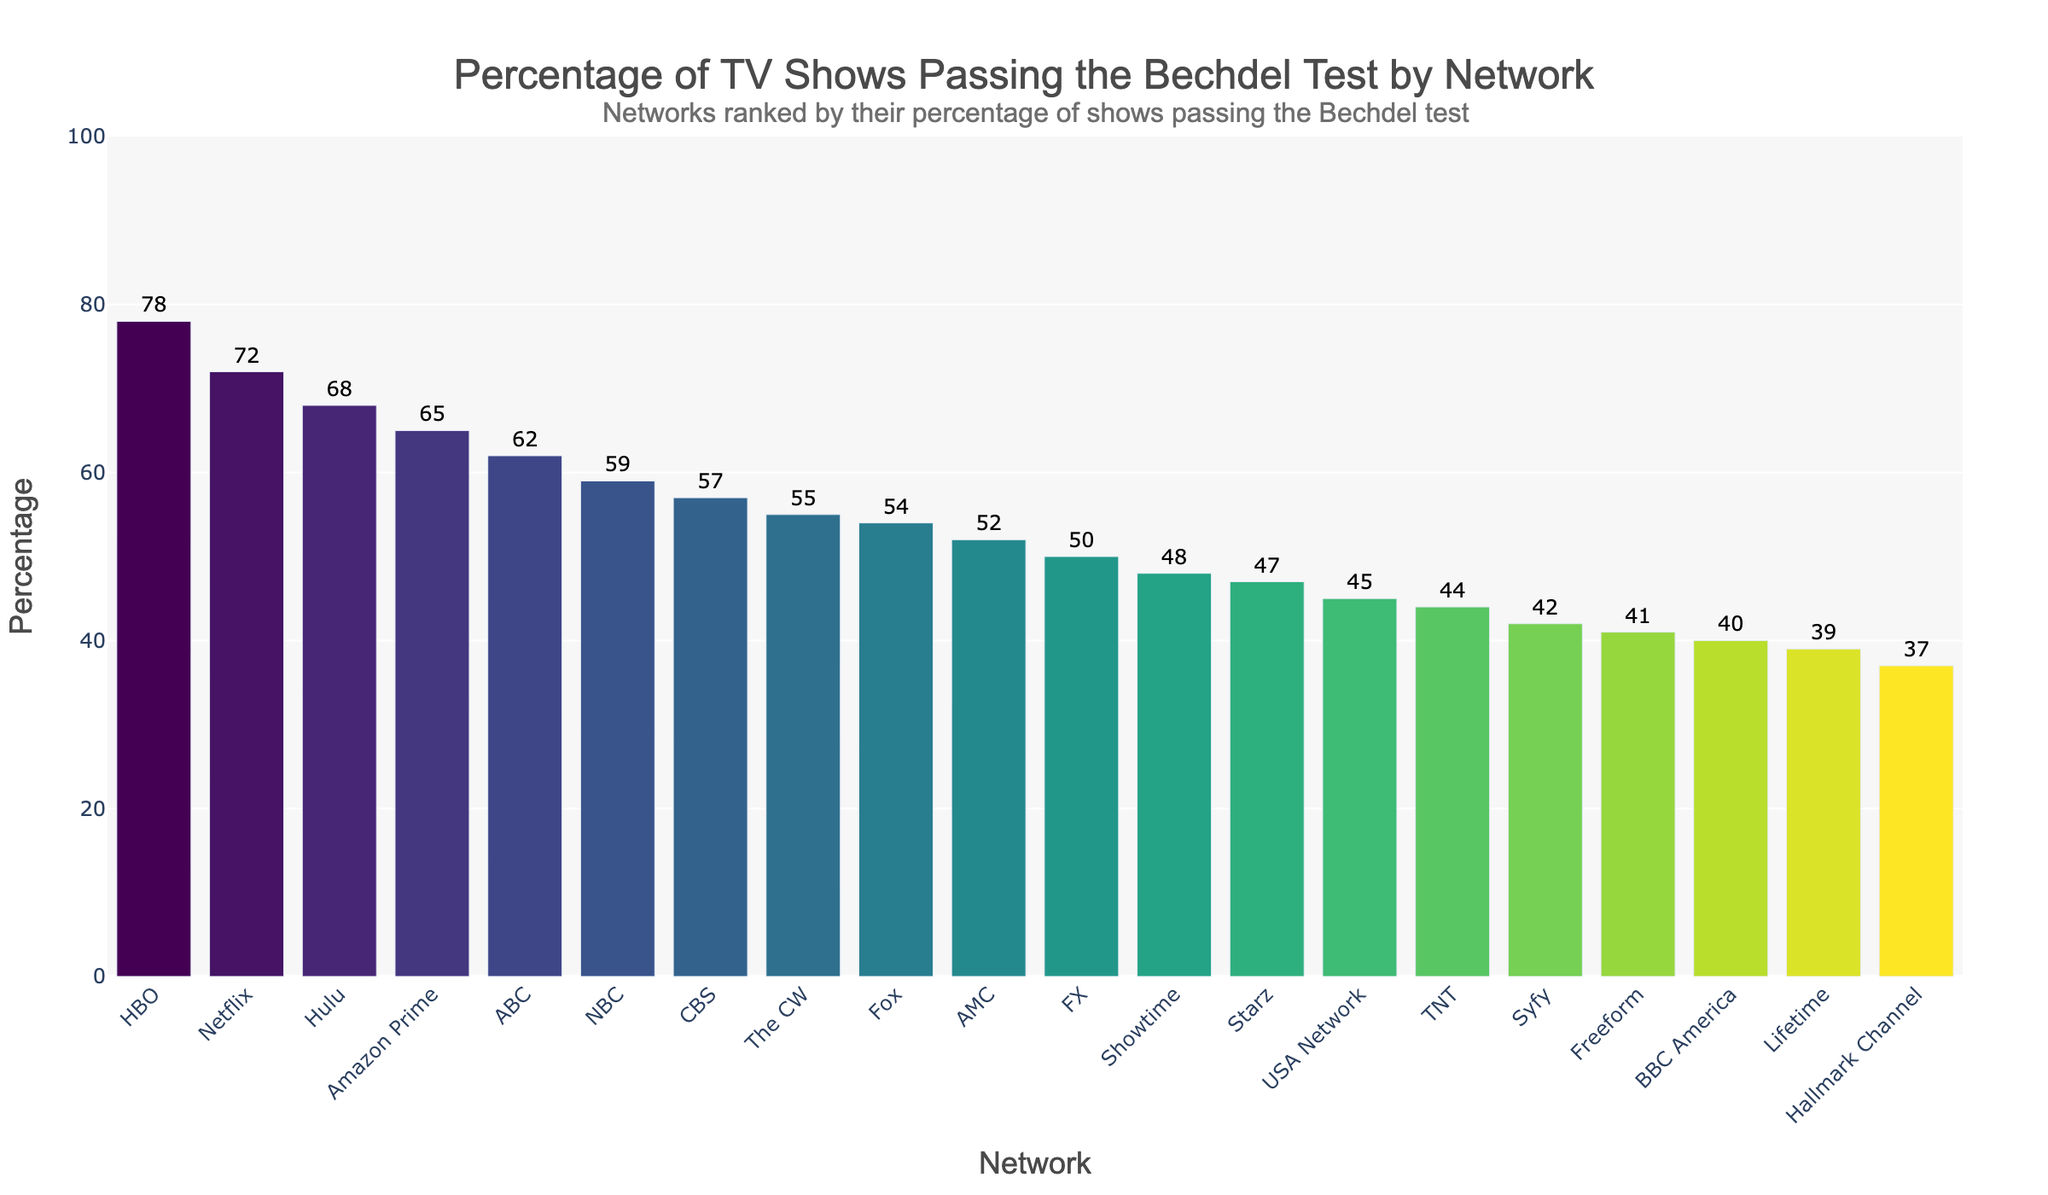What is the network with the highest percentage of TV shows passing the Bechdel test? The bar chart shows various networks and the percentage of TV shows passing the Bechdel test. The highest bar represents HBO with 78%.
Answer: HBO Which network has a higher percentage of TV shows passing the Bechdel test, Hulu or Amazon Prime? By comparing the heights of the bars for Hulu and Amazon Prime, we see that Hulu is at 68% and Amazon Prime is at 65%. Therefore, Hulu has a higher percentage.
Answer: Hulu What is the difference in percentage between the network with the highest and the network with the lowest percentage of TV shows passing the Bechdel test? The network with the highest percentage is HBO at 78%, and the network with the lowest percentage is Hallmark Channel at 37%. The difference is 78% - 37% = 41%.
Answer: 41% Which network is closest to having 50% of its TV shows passing the Bechdel test? Looking at the bars around the 50% mark, FX is shown as having exactly 50% of its TV shows passing the Bechdel test.
Answer: FX How many networks have at least 60% of their TV shows passing the Bechdel test? By counting the bars with percentages above or equal to 60%, the networks are HBO, Netflix, Hulu, Amazon Prime, and ABC. There are a total of 5 networks.
Answer: 5 What is the average percentage of TV shows passing the Bechdel test for NBC, CBS, and The CW? The percentages for NBC, CBS, and The CW are 59%, 57%, and 55%. The sum of these percentages is 59 + 57 + 55 = 171. The average is 171/3 = 57%.
Answer: 57% Which networks have a percentage of TV shows passing the Bechdel test that is higher than the median percentage of all networks? First, we need to find the median percentage. There are 20 data points, so the median is the average of the 10th and 11th values. The 10th and 11th values are AMC (52%) and FX (50%). The median is (52 + 50)/2 = 51%. Networks with more than 51% are HBO, Netflix, Hulu, Amazon Prime, ABC, NBC, CBS, The CW, Fox, and AMC.
Answer: HBO, Netflix, Hulu, Amazon Prime, ABC, NBC, CBS, The CW, Fox, AMC Which network has a smaller percentage of TV shows passing the Bechdel test: BBC America or Lifetime? The bar chart shows BBC America at 40% and Lifetime at 39%. Lifetime has a smaller percentage.
Answer: Lifetime 